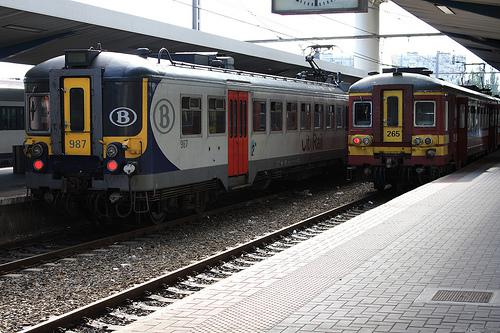Question: how does the weather look?
Choices:
A. Muggy.
B. Sunny.
C. Overcast.
D. Rainy.
Answer with the letter. Answer: C 